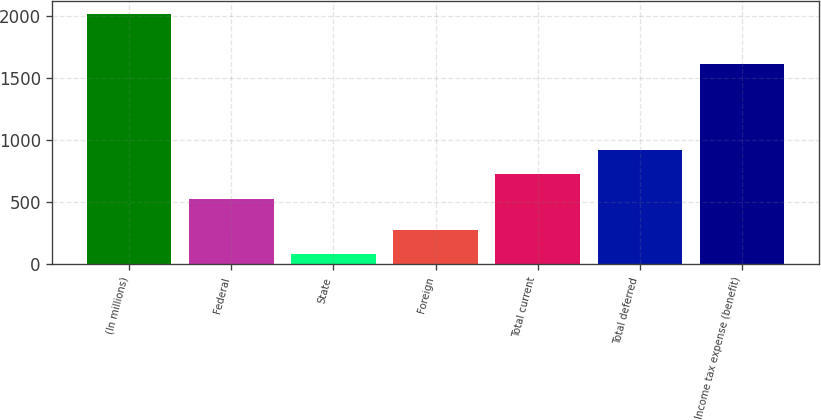<chart> <loc_0><loc_0><loc_500><loc_500><bar_chart><fcel>(In millions)<fcel>Federal<fcel>State<fcel>Foreign<fcel>Total current<fcel>Total deferred<fcel>Income tax expense (benefit)<nl><fcel>2017<fcel>524<fcel>86<fcel>279.1<fcel>732<fcel>925.1<fcel>1614<nl></chart> 